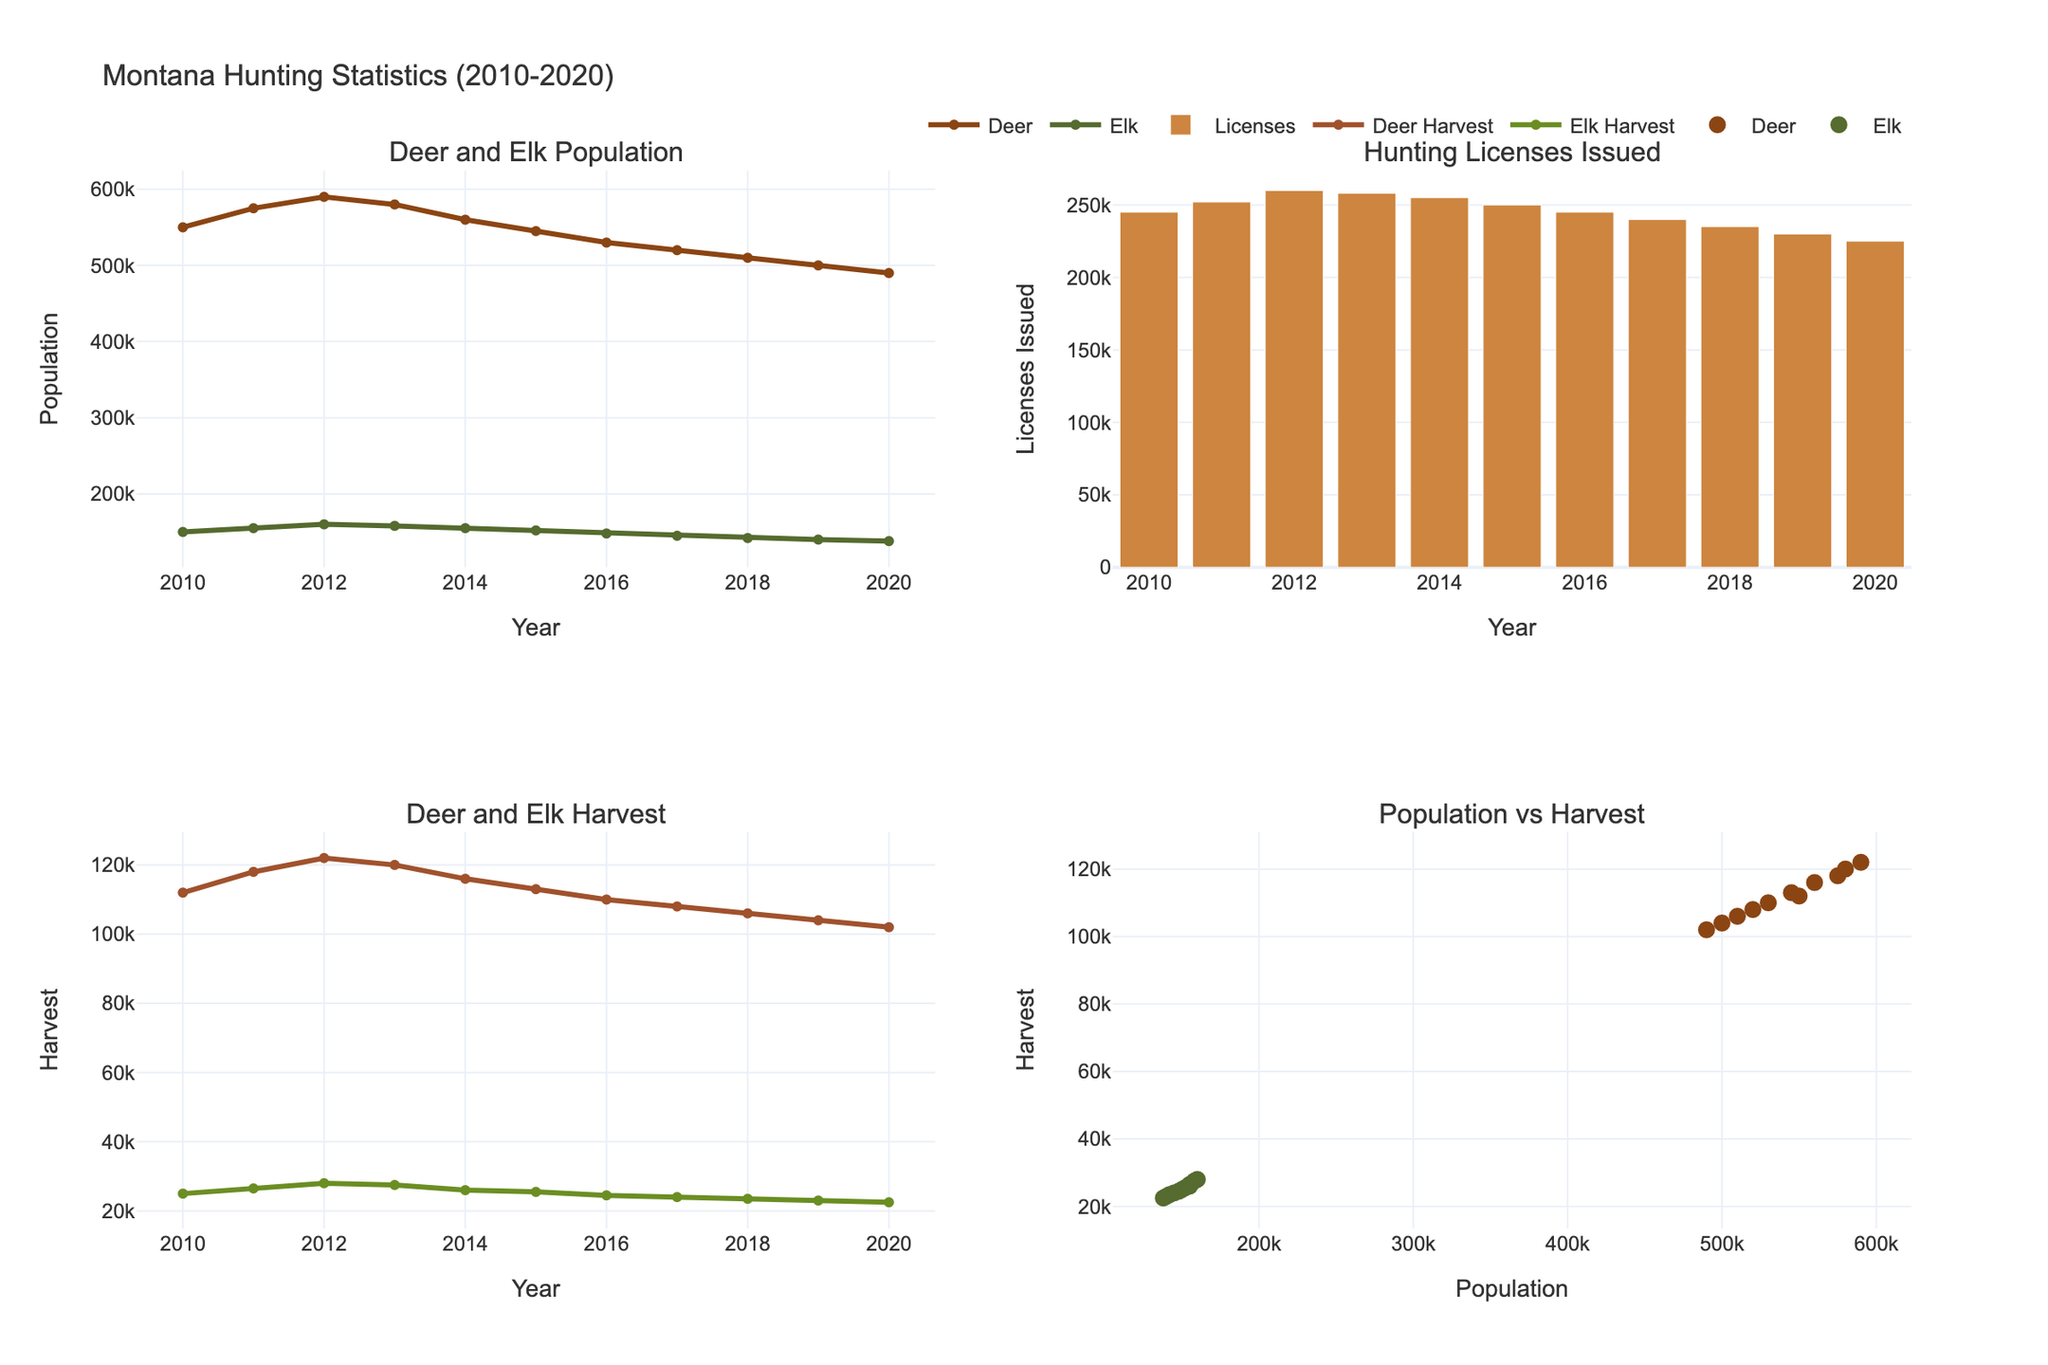What is the title of the figure? The title is typically the most prominent text at the top of the figure. In this case, it is easy to identify due to its position and larger font size.
Answer: Career Progression of UNC Charlotte Alumni (2013-2021) Which major shows the highest entry-level salary in 2021? To determine this, locate the bar charts for 2021 and compare the entry-level salaries across majors. Mechanical Engineering has the highest bar in the Entry_Level category for 2021.
Answer: Mechanical Engineering How many subplots are in the figure? The figure is divided into different sections showing individual majors, which is clear from the varied titles over each section. There are four subplots, each for a different major.
Answer: 4 Between 2013 and 2021, how much did the entry-level salary in Computer Science increase? Look at the entry-level salary for Computer Science in 2013 and 2021. The difference is calculated by subtracting the 2013 value from the 2021 value (60000 - 45000).
Answer: 15000 Which career level in Business Administration saw the greatest salary increase from 2013 to 2021? Calculate the salary difference for each career level within Business Administration from 2013 to 2021. The Management level has the greatest increase (130000 - 100000 = 30000).
Answer: Management What is the average entry-level salary in 2017 across all four majors? Add the entry-level salaries for all majors in 2017 and divide by the number of majors: (52000+45000+56000+40000) / 4.
Answer: 48250 Which career level in Psychology in 2021 has the smallest salary compared to other levels? Compare the bars for all career levels in Psychology for the year 2021. Entry_Level has the smallest salary (45000).
Answer: Entry_Level Does the Management level salary always trend upwards across the years for each major? Examine the line plots for the Management level for each major. All lines trend upwards from 2013 to 2021 for each major.
Answer: Yes Between Business Administration and Psychology, which major saw a greater increase in mid-level salary from 2013 to 2021? Calculate the increase in mid-level salary for both majors from 2013 to 2021: Business Administration (76000-60000=16000) and Psychology (64000-50000=14000). Business Administration's increase is greater.
Answer: Business Administration What is the difference in senior-level salary between Mechanical Engineering and Psychology in 2019? Compare the senior-level salaries in 2019 for both majors by subtracting Psychology's salary (82000) from Mechanical Engineering's salary (106000): 106000 - 82000.
Answer: 24000 